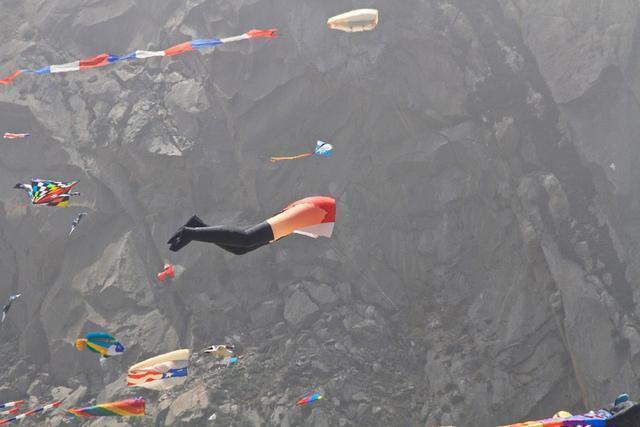What is the most popular kite shape?
From the following set of four choices, select the accurate answer to respond to the question.
Options: Snoopy, diamond/delta/box, dragon, cat. Diamond/delta/box. 